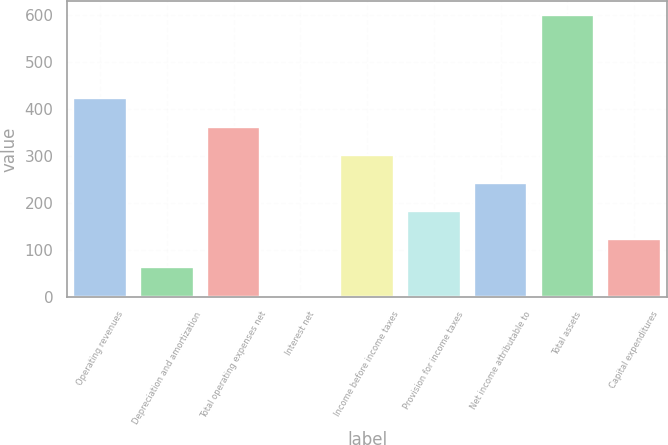<chart> <loc_0><loc_0><loc_500><loc_500><bar_chart><fcel>Operating revenues<fcel>Depreciation and amortization<fcel>Total operating expenses net<fcel>Interest net<fcel>Income before income taxes<fcel>Provision for income taxes<fcel>Net income attributable to<fcel>Total assets<fcel>Capital expenditures<nl><fcel>422<fcel>62.6<fcel>360.6<fcel>3<fcel>301<fcel>181.8<fcel>241.4<fcel>599<fcel>122.2<nl></chart> 